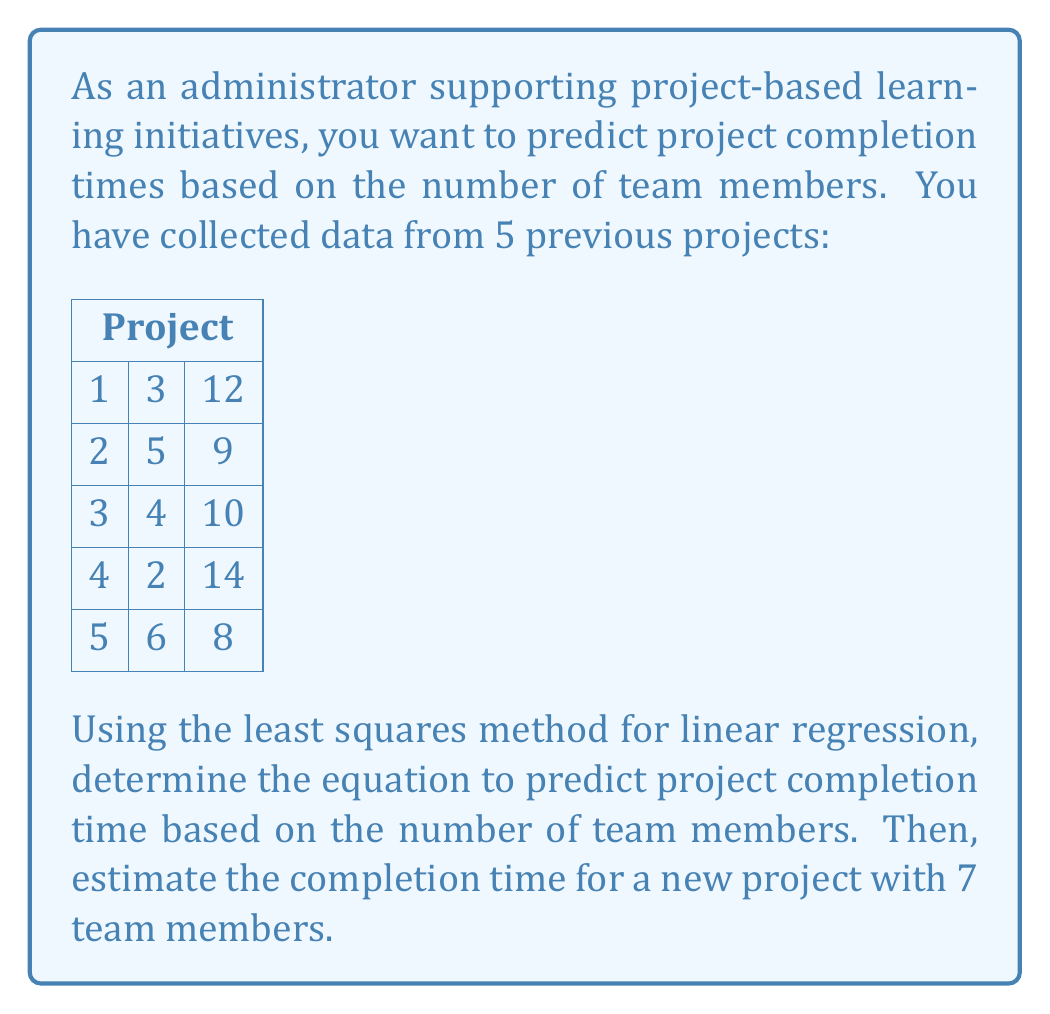Show me your answer to this math problem. To solve this problem, we'll use the least squares method for linear regression. We're looking for an equation in the form $y = mx + b$, where $y$ is the completion time, $x$ is the number of team members, $m$ is the slope, and $b$ is the y-intercept.

Step 1: Calculate the sums we need:
$n = 5$ (number of data points)
$\sum x = 3 + 5 + 4 + 2 + 6 = 20$
$\sum y = 12 + 9 + 10 + 14 + 8 = 53$
$\sum xy = (3)(12) + (5)(9) + (4)(10) + (2)(14) + (6)(8) = 200$
$\sum x^2 = 3^2 + 5^2 + 4^2 + 2^2 + 6^2 = 90$

Step 2: Use the least squares formulas to calculate $m$ and $b$:

$$m = \frac{n\sum xy - \sum x \sum y}{n\sum x^2 - (\sum x)^2}$$

$$m = \frac{5(200) - (20)(53)}{5(90) - (20)^2} = \frac{1000 - 1060}{450 - 400} = \frac{-60}{50} = -1.2$$

$$b = \frac{\sum y - m\sum x}{n}$$

$$b = \frac{53 - (-1.2)(20)}{5} = \frac{53 + 24}{5} = \frac{77}{5} = 15.4$$

Step 3: Write the equation of the line:

$y = -1.2x + 15.4$

This means that for each additional team member, the project completion time is expected to decrease by 1.2 weeks, with a base time of 15.4 weeks.

Step 4: Estimate the completion time for a project with 7 team members:

$y = -1.2(7) + 15.4 = -8.4 + 15.4 = 7$ weeks
Answer: The linear regression equation is $y = -1.2x + 15.4$, where $y$ is the predicted project completion time in weeks and $x$ is the number of team members. The estimated completion time for a project with 7 team members is 7 weeks. 